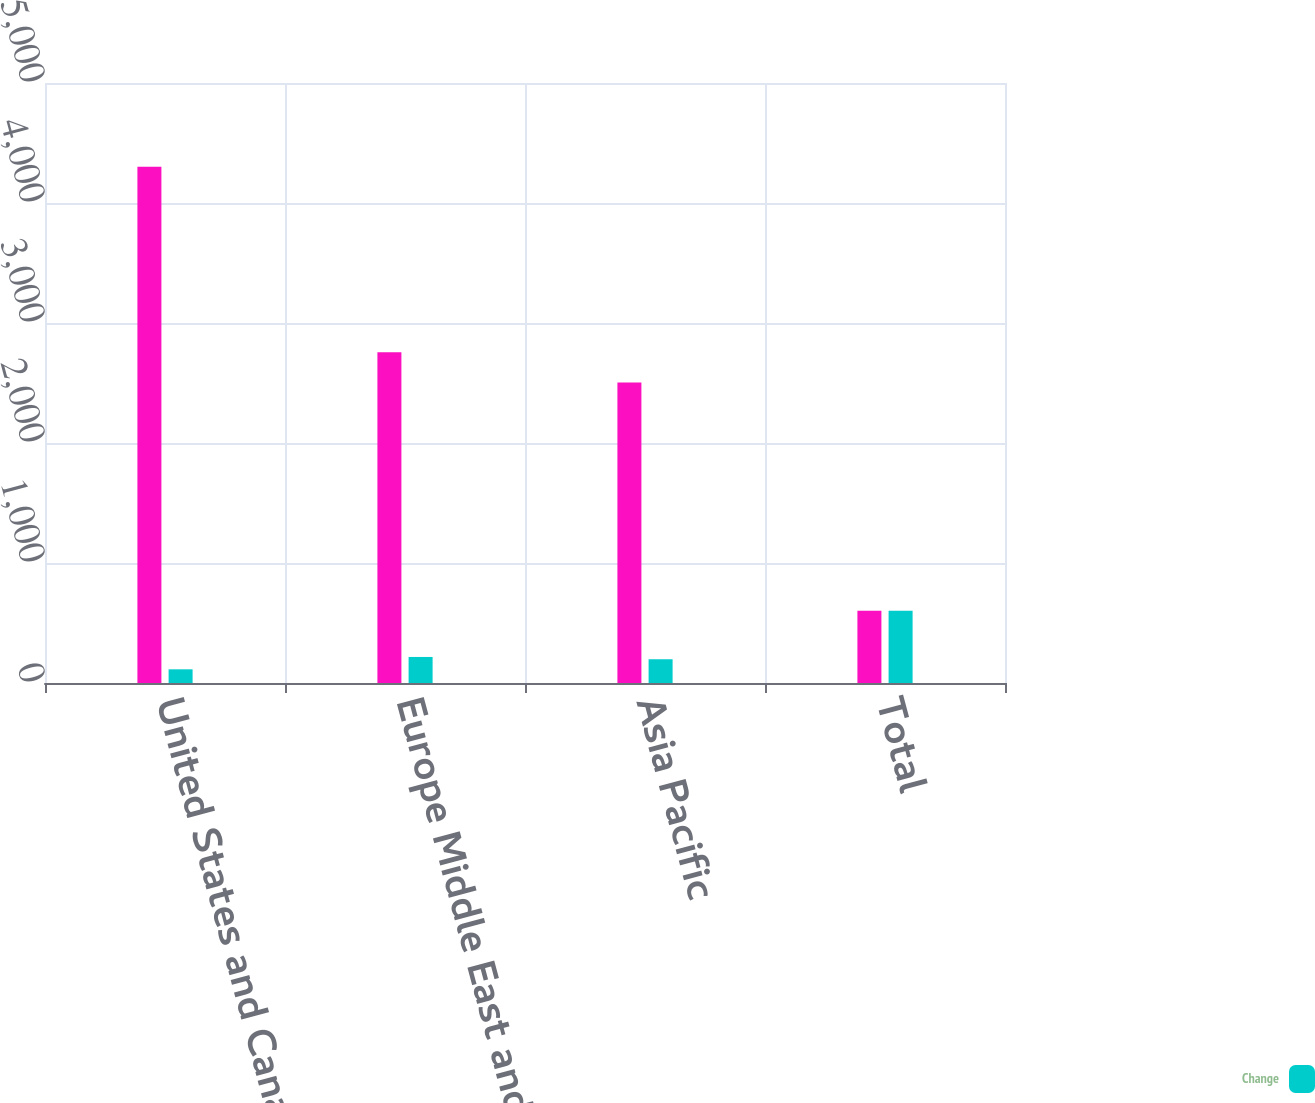Convert chart. <chart><loc_0><loc_0><loc_500><loc_500><stacked_bar_chart><ecel><fcel>United States and Canada<fcel>Europe Middle East and Africa<fcel>Asia Pacific<fcel>Total<nl><fcel>nan<fcel>4303<fcel>2756<fcel>2504<fcel>602<nl><fcel>Change<fcel>114<fcel>217<fcel>198<fcel>602<nl></chart> 